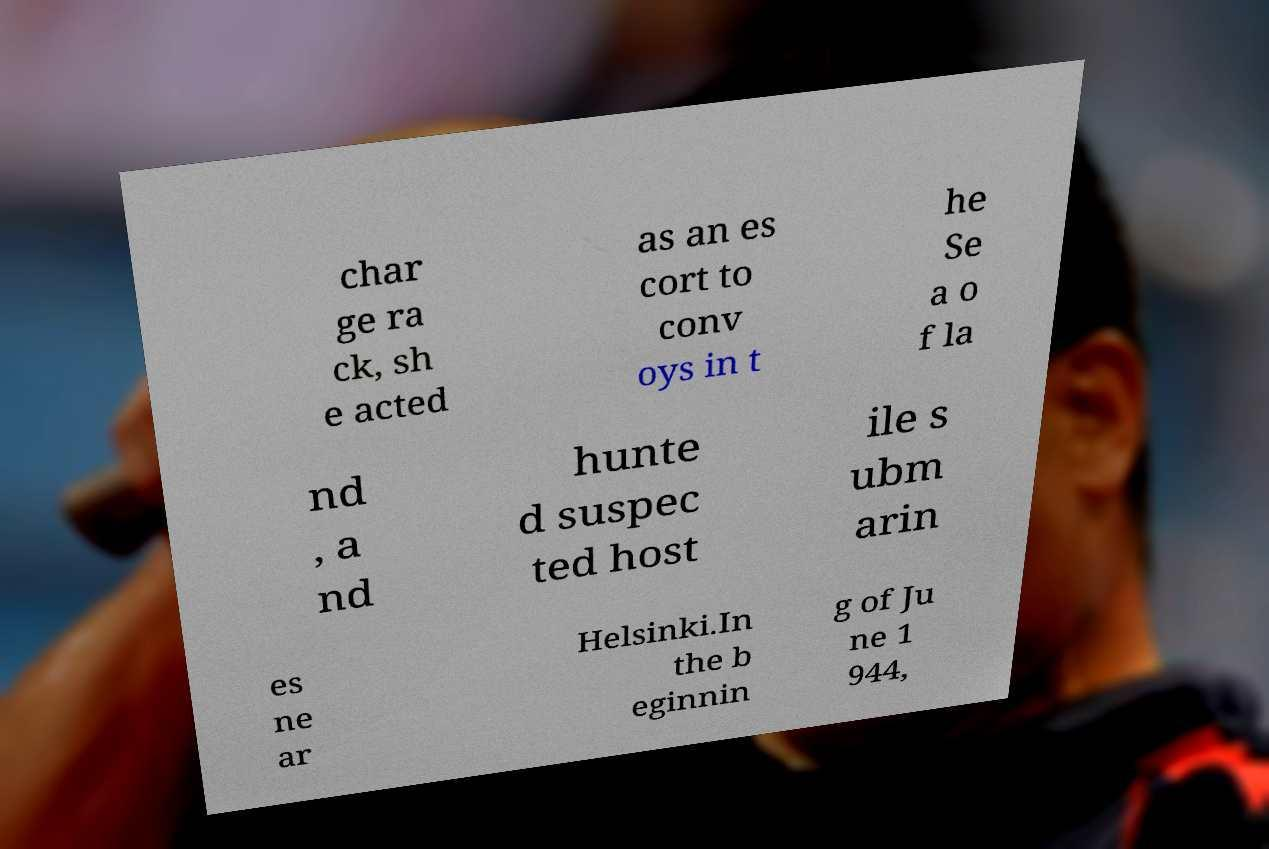What messages or text are displayed in this image? I need them in a readable, typed format. char ge ra ck, sh e acted as an es cort to conv oys in t he Se a o f la nd , a nd hunte d suspec ted host ile s ubm arin es ne ar Helsinki.In the b eginnin g of Ju ne 1 944, 